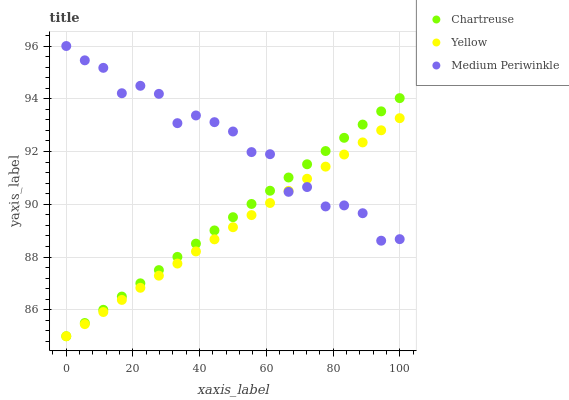Does Yellow have the minimum area under the curve?
Answer yes or no. Yes. Does Medium Periwinkle have the maximum area under the curve?
Answer yes or no. Yes. Does Medium Periwinkle have the minimum area under the curve?
Answer yes or no. No. Does Yellow have the maximum area under the curve?
Answer yes or no. No. Is Chartreuse the smoothest?
Answer yes or no. Yes. Is Medium Periwinkle the roughest?
Answer yes or no. Yes. Is Yellow the smoothest?
Answer yes or no. No. Is Yellow the roughest?
Answer yes or no. No. Does Chartreuse have the lowest value?
Answer yes or no. Yes. Does Medium Periwinkle have the lowest value?
Answer yes or no. No. Does Medium Periwinkle have the highest value?
Answer yes or no. Yes. Does Yellow have the highest value?
Answer yes or no. No. Does Yellow intersect Medium Periwinkle?
Answer yes or no. Yes. Is Yellow less than Medium Periwinkle?
Answer yes or no. No. Is Yellow greater than Medium Periwinkle?
Answer yes or no. No. 